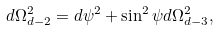Convert formula to latex. <formula><loc_0><loc_0><loc_500><loc_500>d \Omega _ { d - 2 } ^ { 2 } = d \psi ^ { 2 } + \sin ^ { 2 } \psi d \Omega _ { d - 3 } ^ { 2 } ,</formula> 